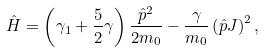Convert formula to latex. <formula><loc_0><loc_0><loc_500><loc_500>\hat { H } = \left ( \gamma _ { 1 } + \frac { 5 } { 2 } \gamma \right ) \frac { \hat { p } ^ { 2 } } { 2 m _ { 0 } } - \frac { \gamma } { m _ { 0 } } \left ( \hat { p } { J } \right ) ^ { 2 } ,</formula> 